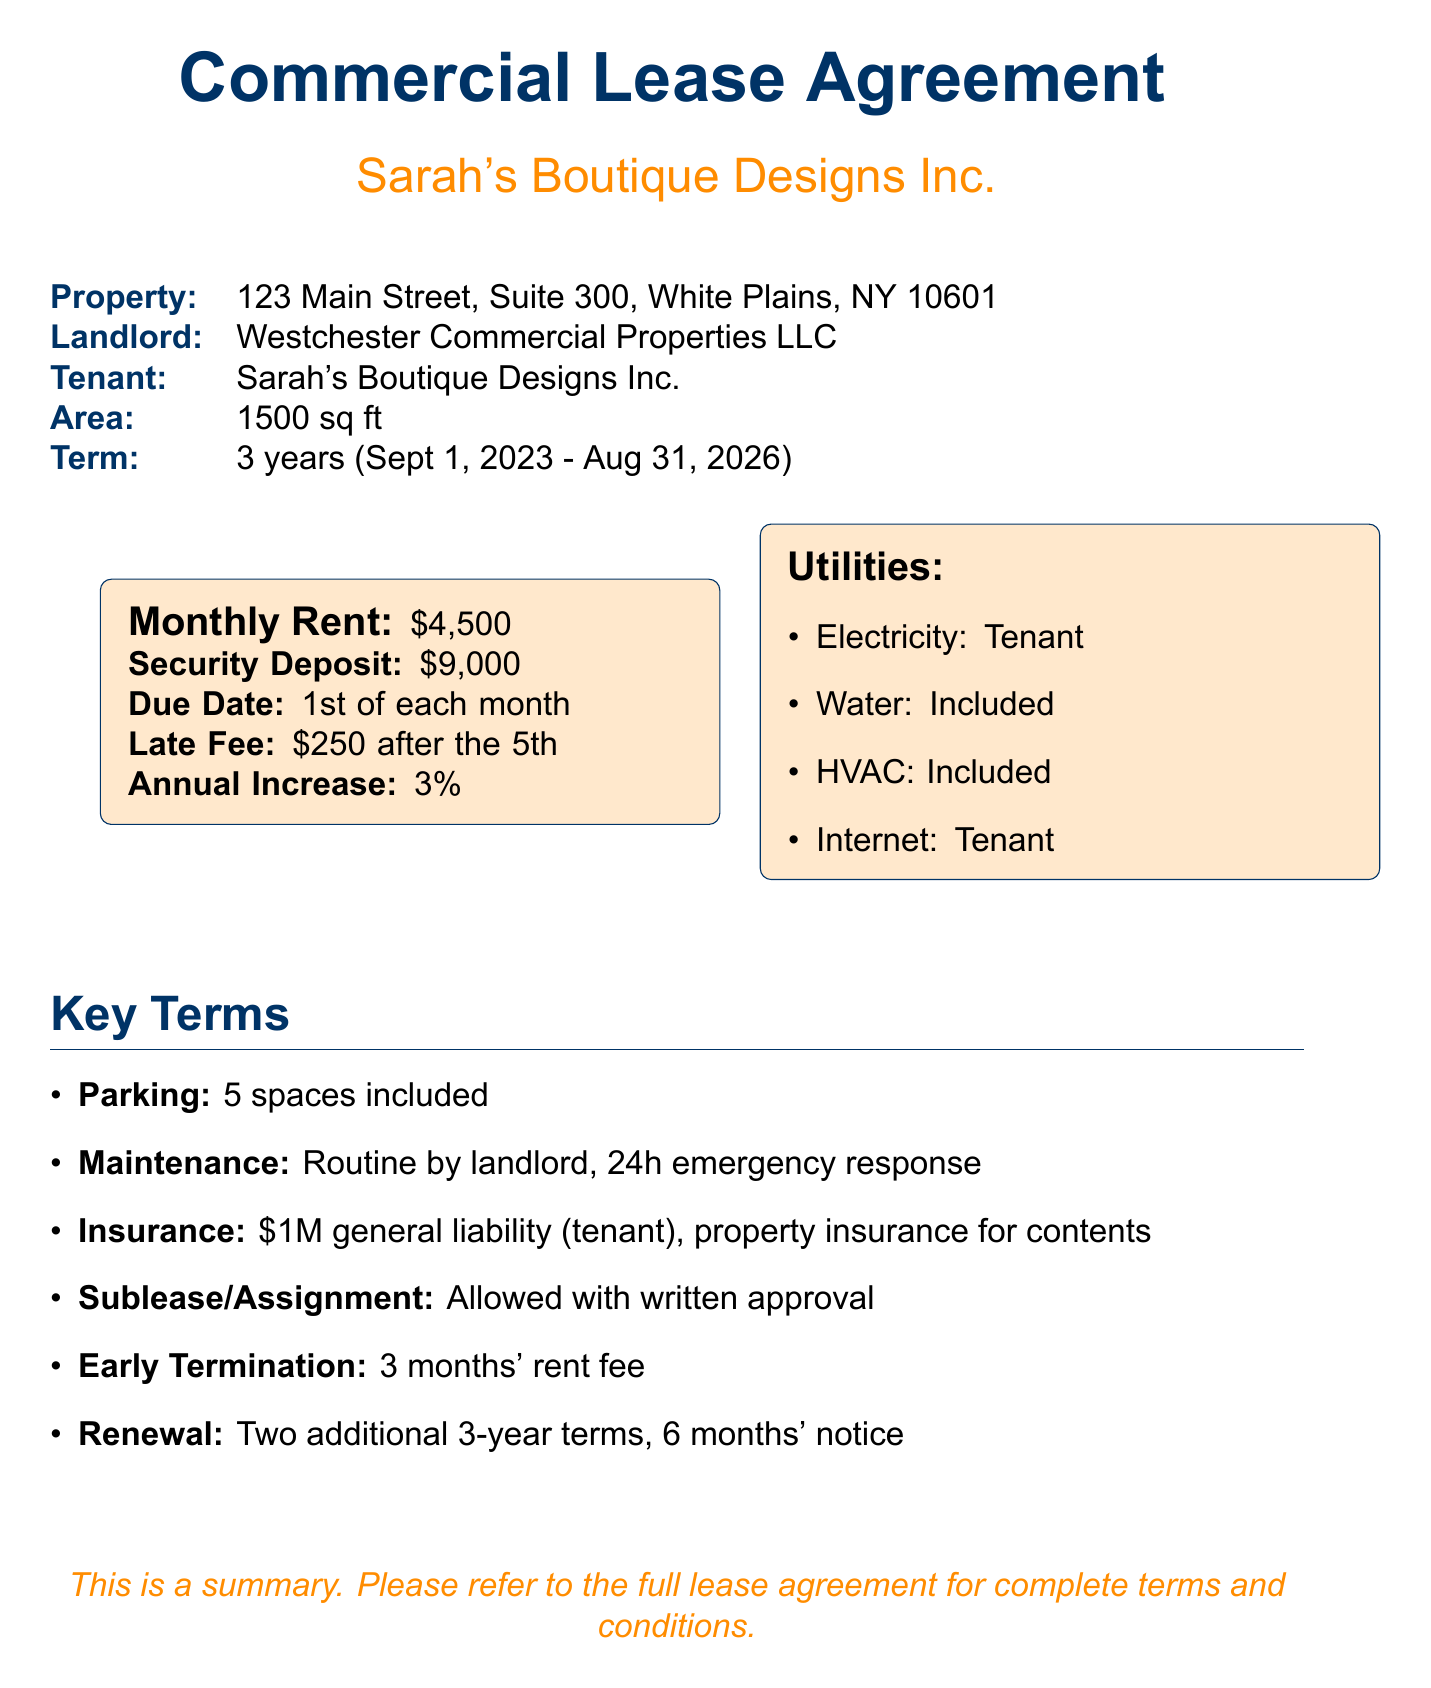What is the monthly rent? The monthly rent is explicitly stated in the lease details section of the document as $4,500.
Answer: $4,500 What is the duration of the lease? The lease duration is mentioned as 3 years, with specific start and end dates detailed in the document.
Answer: 3 years Who is the landlord? The landlord's name is listed in the property details section as Westchester Commercial Properties LLC.
Answer: Westchester Commercial Properties LLC What is the early termination fee? The document specifies the early termination fee as 3 months' rent, indicated in the termination and renewal section.
Answer: 3 months' rent Is water included in the rent? The utilities and services section states that water is included, confirming this essential detail.
Answer: Included What is the security deposit amount? The security deposit amount is provided in the lease details section as $9,000.
Answer: $9,000 What is required for subleasing the space? The sublease and assignment section specifies that subleasing is allowed with written landlord approval.
Answer: Written landlord approval How many parking spaces are included? The property features section states that 5 parking spaces are included with the lease agreement.
Answer: 5 spaces What is the late fee for rent payment? The rent payment details outline a late fee of $250 if rent is paid after the 5th of each month.
Answer: $250 